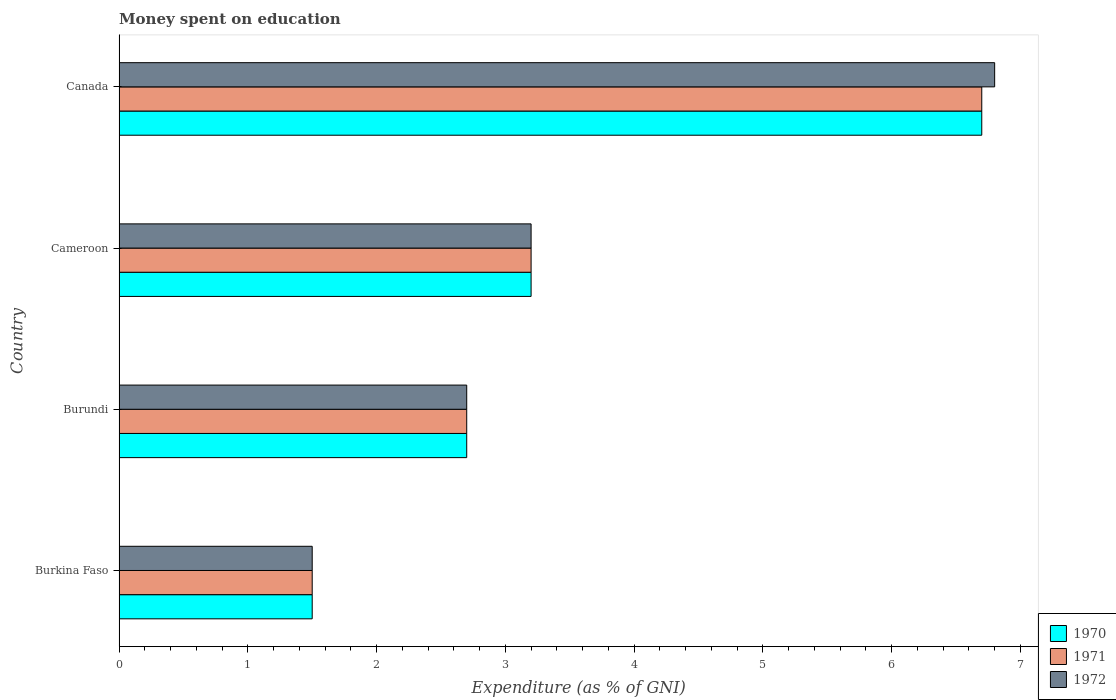How many different coloured bars are there?
Provide a succinct answer. 3. How many groups of bars are there?
Your answer should be compact. 4. Are the number of bars per tick equal to the number of legend labels?
Your answer should be compact. Yes. Are the number of bars on each tick of the Y-axis equal?
Your response must be concise. Yes. How many bars are there on the 3rd tick from the top?
Your answer should be very brief. 3. What is the label of the 2nd group of bars from the top?
Ensure brevity in your answer.  Cameroon. In how many cases, is the number of bars for a given country not equal to the number of legend labels?
Your answer should be compact. 0. What is the amount of money spent on education in 1971 in Cameroon?
Your answer should be very brief. 3.2. In which country was the amount of money spent on education in 1972 minimum?
Keep it short and to the point. Burkina Faso. What is the total amount of money spent on education in 1971 in the graph?
Keep it short and to the point. 14.1. What is the difference between the amount of money spent on education in 1971 in Burkina Faso and that in Canada?
Keep it short and to the point. -5.2. What is the average amount of money spent on education in 1972 per country?
Keep it short and to the point. 3.55. What is the difference between the amount of money spent on education in 1971 and amount of money spent on education in 1970 in Cameroon?
Give a very brief answer. 0. In how many countries, is the amount of money spent on education in 1971 greater than 4.6 %?
Offer a terse response. 1. What is the ratio of the amount of money spent on education in 1970 in Burundi to that in Cameroon?
Provide a short and direct response. 0.84. Is the amount of money spent on education in 1972 in Burundi less than that in Canada?
Your answer should be very brief. Yes. What is the difference between the highest and the lowest amount of money spent on education in 1971?
Your answer should be very brief. 5.2. In how many countries, is the amount of money spent on education in 1970 greater than the average amount of money spent on education in 1970 taken over all countries?
Provide a succinct answer. 1. Is the sum of the amount of money spent on education in 1972 in Burkina Faso and Cameroon greater than the maximum amount of money spent on education in 1971 across all countries?
Your response must be concise. No. What does the 2nd bar from the top in Cameroon represents?
Ensure brevity in your answer.  1971. What does the 2nd bar from the bottom in Burkina Faso represents?
Keep it short and to the point. 1971. Is it the case that in every country, the sum of the amount of money spent on education in 1970 and amount of money spent on education in 1972 is greater than the amount of money spent on education in 1971?
Offer a terse response. Yes. How many bars are there?
Provide a short and direct response. 12. How many countries are there in the graph?
Offer a terse response. 4. What is the difference between two consecutive major ticks on the X-axis?
Offer a very short reply. 1. Are the values on the major ticks of X-axis written in scientific E-notation?
Offer a very short reply. No. Where does the legend appear in the graph?
Provide a succinct answer. Bottom right. How many legend labels are there?
Make the answer very short. 3. What is the title of the graph?
Provide a succinct answer. Money spent on education. What is the label or title of the X-axis?
Your answer should be very brief. Expenditure (as % of GNI). What is the Expenditure (as % of GNI) in 1970 in Burkina Faso?
Provide a succinct answer. 1.5. What is the Expenditure (as % of GNI) in 1971 in Burkina Faso?
Keep it short and to the point. 1.5. What is the Expenditure (as % of GNI) of 1971 in Burundi?
Your answer should be very brief. 2.7. What is the Expenditure (as % of GNI) of 1970 in Cameroon?
Keep it short and to the point. 3.2. What is the Expenditure (as % of GNI) in 1971 in Cameroon?
Your answer should be very brief. 3.2. What is the Expenditure (as % of GNI) in 1972 in Cameroon?
Give a very brief answer. 3.2. What is the Expenditure (as % of GNI) of 1971 in Canada?
Offer a terse response. 6.7. What is the Expenditure (as % of GNI) of 1972 in Canada?
Make the answer very short. 6.8. Across all countries, what is the maximum Expenditure (as % of GNI) in 1970?
Provide a succinct answer. 6.7. Across all countries, what is the maximum Expenditure (as % of GNI) of 1971?
Make the answer very short. 6.7. Across all countries, what is the maximum Expenditure (as % of GNI) of 1972?
Provide a short and direct response. 6.8. Across all countries, what is the minimum Expenditure (as % of GNI) of 1970?
Make the answer very short. 1.5. Across all countries, what is the minimum Expenditure (as % of GNI) of 1971?
Offer a very short reply. 1.5. What is the total Expenditure (as % of GNI) of 1970 in the graph?
Your response must be concise. 14.1. What is the total Expenditure (as % of GNI) in 1971 in the graph?
Offer a terse response. 14.1. What is the difference between the Expenditure (as % of GNI) of 1970 in Burkina Faso and that in Burundi?
Give a very brief answer. -1.2. What is the difference between the Expenditure (as % of GNI) of 1971 in Burkina Faso and that in Burundi?
Provide a succinct answer. -1.2. What is the difference between the Expenditure (as % of GNI) in 1972 in Burkina Faso and that in Burundi?
Your answer should be compact. -1.2. What is the difference between the Expenditure (as % of GNI) of 1971 in Burkina Faso and that in Cameroon?
Your answer should be very brief. -1.7. What is the difference between the Expenditure (as % of GNI) in 1972 in Burkina Faso and that in Cameroon?
Offer a terse response. -1.7. What is the difference between the Expenditure (as % of GNI) in 1970 in Burkina Faso and that in Canada?
Your answer should be compact. -5.2. What is the difference between the Expenditure (as % of GNI) of 1972 in Burkina Faso and that in Canada?
Provide a succinct answer. -5.3. What is the difference between the Expenditure (as % of GNI) in 1970 in Burundi and that in Cameroon?
Provide a succinct answer. -0.5. What is the difference between the Expenditure (as % of GNI) of 1971 in Burundi and that in Cameroon?
Offer a very short reply. -0.5. What is the difference between the Expenditure (as % of GNI) in 1970 in Burundi and that in Canada?
Make the answer very short. -4. What is the difference between the Expenditure (as % of GNI) of 1972 in Burundi and that in Canada?
Give a very brief answer. -4.1. What is the difference between the Expenditure (as % of GNI) of 1970 in Cameroon and that in Canada?
Your response must be concise. -3.5. What is the difference between the Expenditure (as % of GNI) of 1971 in Cameroon and that in Canada?
Your answer should be very brief. -3.5. What is the difference between the Expenditure (as % of GNI) in 1970 in Burkina Faso and the Expenditure (as % of GNI) in 1971 in Burundi?
Provide a short and direct response. -1.2. What is the difference between the Expenditure (as % of GNI) in 1971 in Burkina Faso and the Expenditure (as % of GNI) in 1972 in Burundi?
Offer a very short reply. -1.2. What is the difference between the Expenditure (as % of GNI) in 1970 in Burkina Faso and the Expenditure (as % of GNI) in 1972 in Cameroon?
Provide a succinct answer. -1.7. What is the difference between the Expenditure (as % of GNI) of 1971 in Burkina Faso and the Expenditure (as % of GNI) of 1972 in Cameroon?
Your answer should be very brief. -1.7. What is the difference between the Expenditure (as % of GNI) in 1970 in Burkina Faso and the Expenditure (as % of GNI) in 1971 in Canada?
Keep it short and to the point. -5.2. What is the difference between the Expenditure (as % of GNI) in 1970 in Burkina Faso and the Expenditure (as % of GNI) in 1972 in Canada?
Make the answer very short. -5.3. What is the difference between the Expenditure (as % of GNI) in 1970 in Burundi and the Expenditure (as % of GNI) in 1971 in Canada?
Keep it short and to the point. -4. What is the difference between the Expenditure (as % of GNI) of 1970 in Burundi and the Expenditure (as % of GNI) of 1972 in Canada?
Your response must be concise. -4.1. What is the difference between the Expenditure (as % of GNI) of 1971 in Burundi and the Expenditure (as % of GNI) of 1972 in Canada?
Keep it short and to the point. -4.1. What is the average Expenditure (as % of GNI) in 1970 per country?
Your answer should be compact. 3.52. What is the average Expenditure (as % of GNI) in 1971 per country?
Your answer should be compact. 3.52. What is the average Expenditure (as % of GNI) of 1972 per country?
Keep it short and to the point. 3.55. What is the difference between the Expenditure (as % of GNI) in 1970 and Expenditure (as % of GNI) in 1971 in Burkina Faso?
Give a very brief answer. 0. What is the difference between the Expenditure (as % of GNI) in 1970 and Expenditure (as % of GNI) in 1971 in Burundi?
Your response must be concise. 0. What is the difference between the Expenditure (as % of GNI) in 1971 and Expenditure (as % of GNI) in 1972 in Burundi?
Offer a very short reply. 0. What is the difference between the Expenditure (as % of GNI) in 1970 and Expenditure (as % of GNI) in 1972 in Cameroon?
Give a very brief answer. 0. What is the difference between the Expenditure (as % of GNI) of 1970 and Expenditure (as % of GNI) of 1972 in Canada?
Provide a short and direct response. -0.1. What is the difference between the Expenditure (as % of GNI) in 1971 and Expenditure (as % of GNI) in 1972 in Canada?
Your answer should be compact. -0.1. What is the ratio of the Expenditure (as % of GNI) of 1970 in Burkina Faso to that in Burundi?
Your answer should be very brief. 0.56. What is the ratio of the Expenditure (as % of GNI) in 1971 in Burkina Faso to that in Burundi?
Ensure brevity in your answer.  0.56. What is the ratio of the Expenditure (as % of GNI) of 1972 in Burkina Faso to that in Burundi?
Offer a very short reply. 0.56. What is the ratio of the Expenditure (as % of GNI) of 1970 in Burkina Faso to that in Cameroon?
Ensure brevity in your answer.  0.47. What is the ratio of the Expenditure (as % of GNI) in 1971 in Burkina Faso to that in Cameroon?
Offer a very short reply. 0.47. What is the ratio of the Expenditure (as % of GNI) of 1972 in Burkina Faso to that in Cameroon?
Provide a succinct answer. 0.47. What is the ratio of the Expenditure (as % of GNI) in 1970 in Burkina Faso to that in Canada?
Give a very brief answer. 0.22. What is the ratio of the Expenditure (as % of GNI) in 1971 in Burkina Faso to that in Canada?
Ensure brevity in your answer.  0.22. What is the ratio of the Expenditure (as % of GNI) in 1972 in Burkina Faso to that in Canada?
Offer a terse response. 0.22. What is the ratio of the Expenditure (as % of GNI) in 1970 in Burundi to that in Cameroon?
Keep it short and to the point. 0.84. What is the ratio of the Expenditure (as % of GNI) of 1971 in Burundi to that in Cameroon?
Make the answer very short. 0.84. What is the ratio of the Expenditure (as % of GNI) in 1972 in Burundi to that in Cameroon?
Your answer should be very brief. 0.84. What is the ratio of the Expenditure (as % of GNI) in 1970 in Burundi to that in Canada?
Your response must be concise. 0.4. What is the ratio of the Expenditure (as % of GNI) of 1971 in Burundi to that in Canada?
Your answer should be very brief. 0.4. What is the ratio of the Expenditure (as % of GNI) of 1972 in Burundi to that in Canada?
Offer a very short reply. 0.4. What is the ratio of the Expenditure (as % of GNI) of 1970 in Cameroon to that in Canada?
Offer a very short reply. 0.48. What is the ratio of the Expenditure (as % of GNI) of 1971 in Cameroon to that in Canada?
Your answer should be compact. 0.48. What is the ratio of the Expenditure (as % of GNI) of 1972 in Cameroon to that in Canada?
Provide a short and direct response. 0.47. What is the difference between the highest and the second highest Expenditure (as % of GNI) of 1970?
Your response must be concise. 3.5. What is the difference between the highest and the second highest Expenditure (as % of GNI) of 1971?
Your answer should be very brief. 3.5. What is the difference between the highest and the lowest Expenditure (as % of GNI) of 1971?
Your response must be concise. 5.2. What is the difference between the highest and the lowest Expenditure (as % of GNI) of 1972?
Your answer should be very brief. 5.3. 